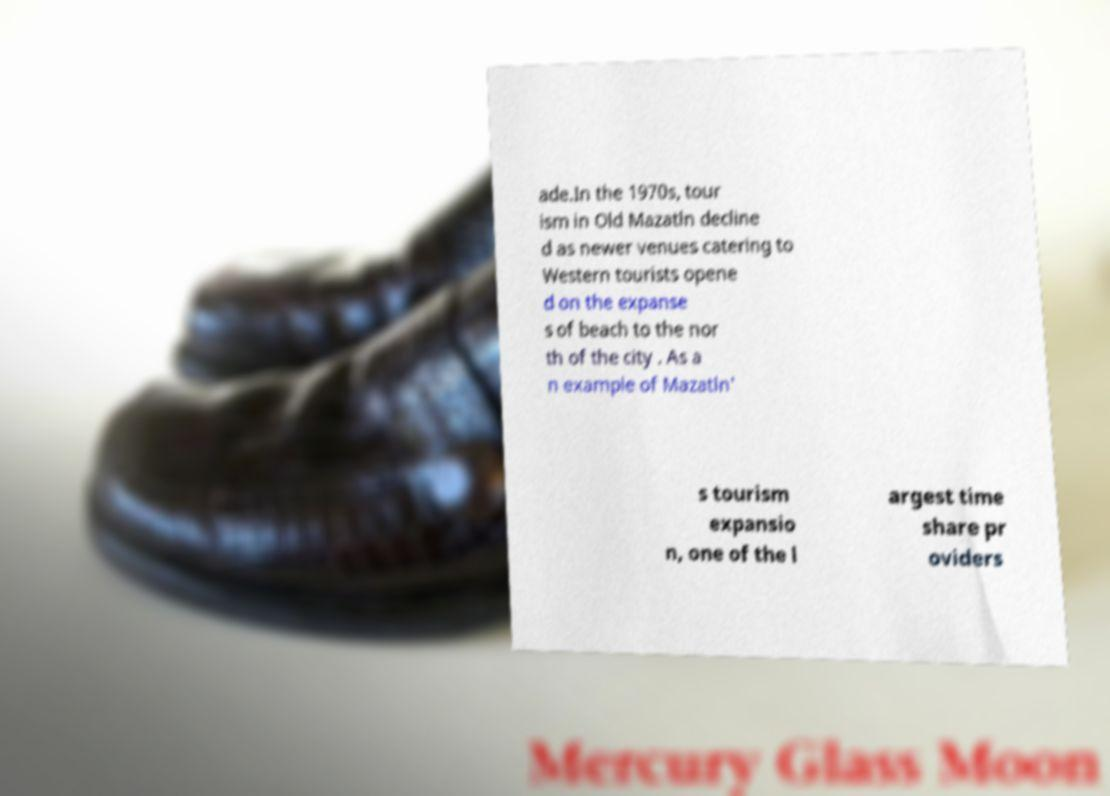Please identify and transcribe the text found in this image. ade.In the 1970s, tour ism in Old Mazatln decline d as newer venues catering to Western tourists opene d on the expanse s of beach to the nor th of the city . As a n example of Mazatln' s tourism expansio n, one of the l argest time share pr oviders 